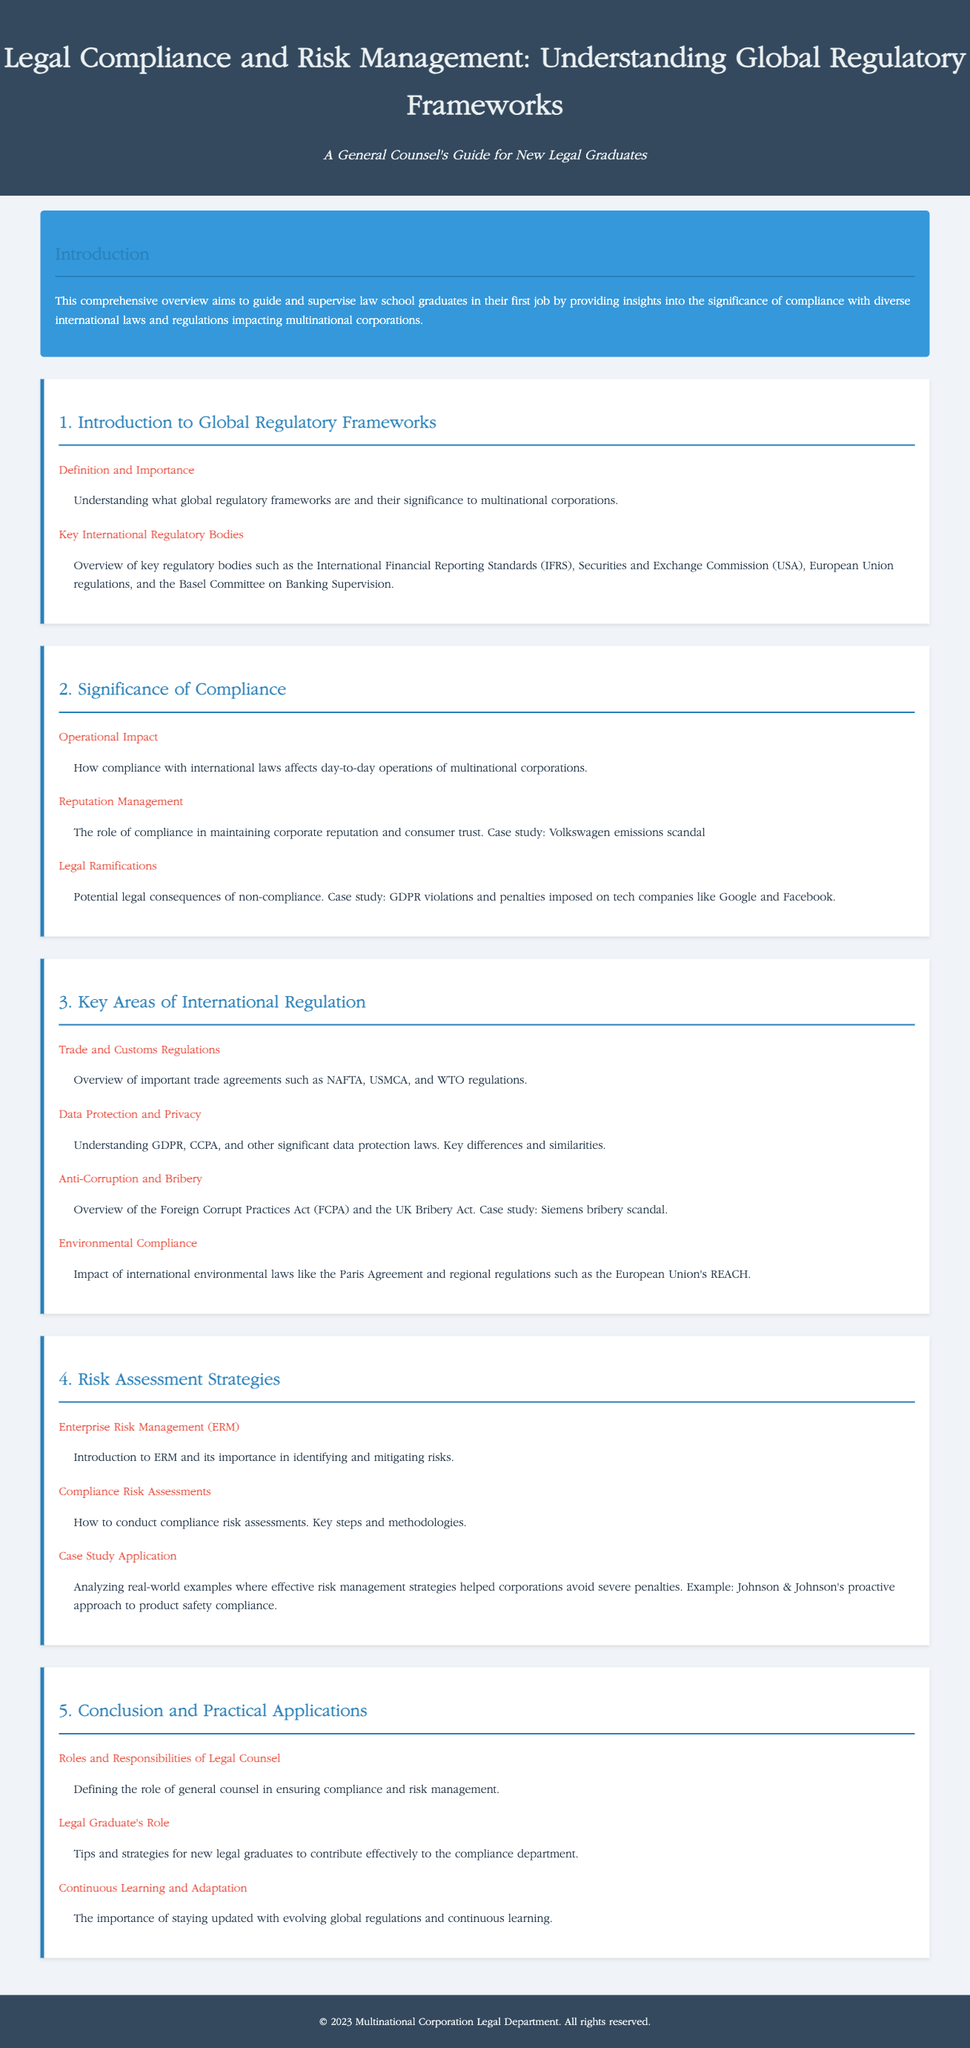what is the title of the lesson plan? The title of the lesson plan is displayed prominently at the top of the document.
Answer: Legal Compliance and Risk Management: Understanding Global Regulatory Frameworks what is the purpose of the lesson plan? The purpose of the lesson plan is mentioned in the introduction section.
Answer: To guide and supervise law school graduates in their first job name one key international regulatory body highlighted in the document. The document provides a list of regulatory bodies in the first section.
Answer: International Financial Reporting Standards (IFRS) what are the legal ramifications discussed in the lesson plan? This is mentioned in Section 2 and includes specific case studies and their implications.
Answer: Potential legal consequences of non-compliance what is one example of a case study for reputation management? The specific case study is outlined under significance of compliance.
Answer: Volkswagen emissions scandal what does ERM stand for in the context of risk assessment strategies? The acronym is mentioned within the context of the risk management section.
Answer: Enterprise Risk Management how many sections are in the lesson plan? The number of sections can be counted from the headings throughout the document.
Answer: Five what is the role of general counsel according to the lesson plan? The role is defined in the conclusion section as part of the responsibilities outlined in the lesson plan.
Answer: Ensuring compliance and risk management 